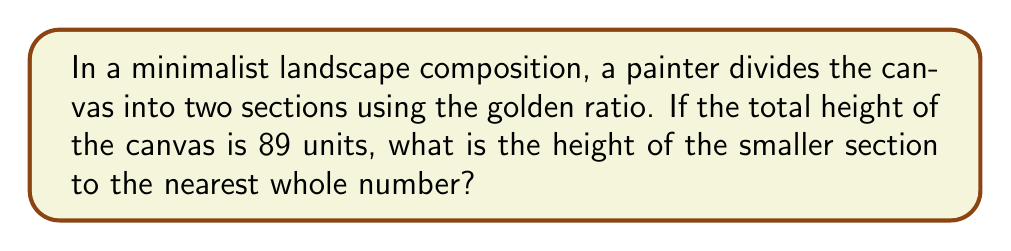What is the answer to this math problem? To solve this problem, we'll use the properties of the golden ratio and apply them to the canvas height:

1. The golden ratio, denoted by φ (phi), is approximately equal to 1.618033988749895.

2. In a composition divided according to the golden ratio, the ratio of the larger part to the smaller part is equal to φ.

3. Let's denote the height of the smaller section as x. Then, the height of the larger section will be 89 - x.

4. We can set up the following equation:

   $$ \frac{89 - x}{x} = φ $$

5. Substituting the value of φ:

   $$ \frac{89 - x}{x} = 1.618033988749895 $$

6. Cross-multiply:

   $$ 89 - x = 1.618033988749895x $$

7. Simplify:

   $$ 89 = 2.618033988749895x $$

8. Solve for x:

   $$ x = \frac{89}{2.618033988749895} ≈ 33.9948... $$

9. Rounding to the nearest whole number:

   $$ x ≈ 34 $$

Thus, the height of the smaller section should be 34 units.
Answer: 34 units 